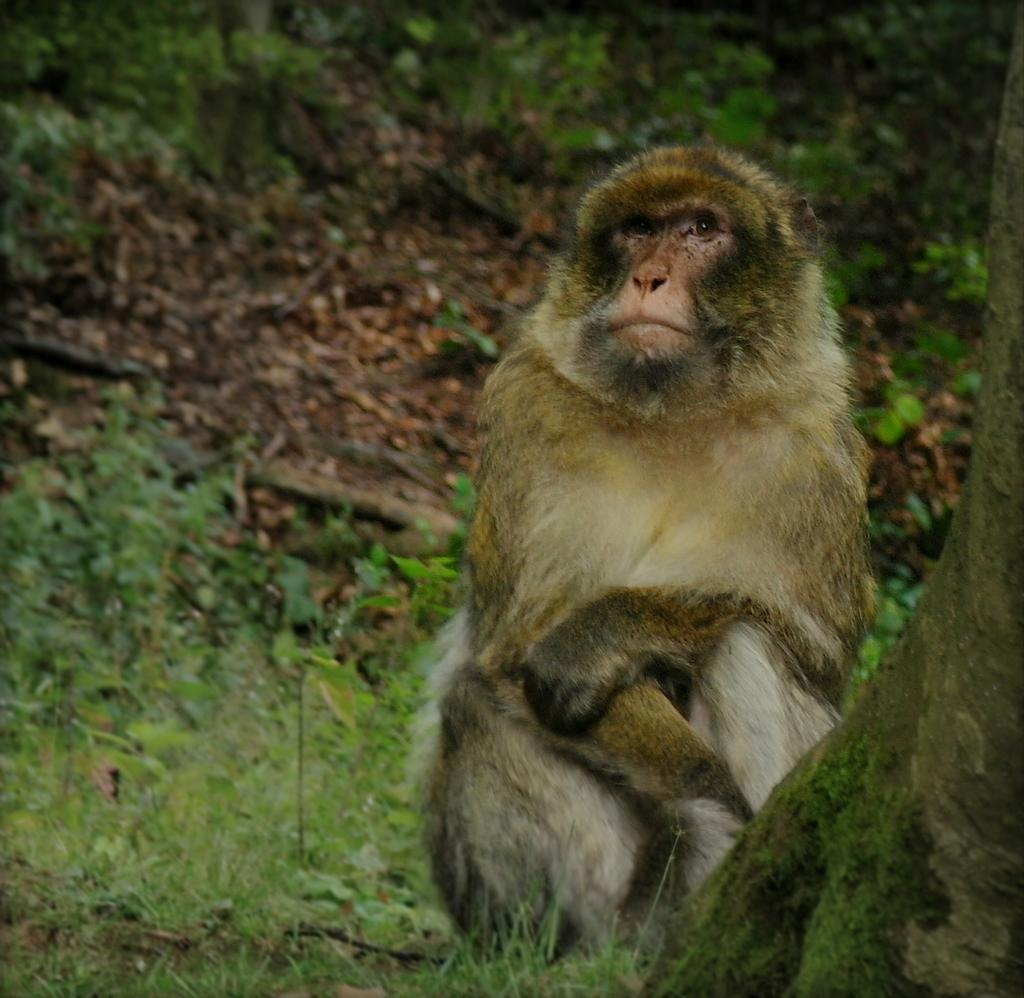What animal is present in the image? There is a monkey in the image. Where is the monkey located? The monkey is sitting on the grass. What color is the grass that the monkey is sitting on? The grass is green. What team does the monkey belong to in the image? There is no indication in the image that the monkey belongs to a team. 